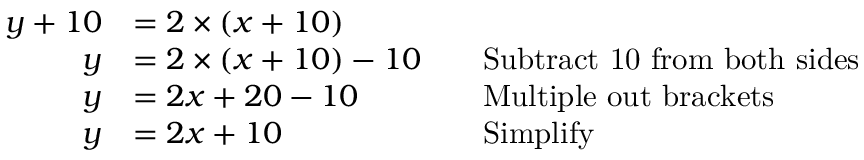<formula> <loc_0><loc_0><loc_500><loc_500>{ \begin{array} { r l r l } { y + 1 0 } & { = 2 \times ( x + 1 0 ) } \\ { y } & { = 2 \times ( x + 1 0 ) - 1 0 } & & { S u b t r a c t 1 0 f r o m b o t h s i d e s } \\ { y } & { = 2 x + 2 0 - 1 0 } & & { M u l t i p l e o u t b r a c k e t s } \\ { y } & { = 2 x + 1 0 } & & { S i m p l i f y } \end{array} }</formula> 